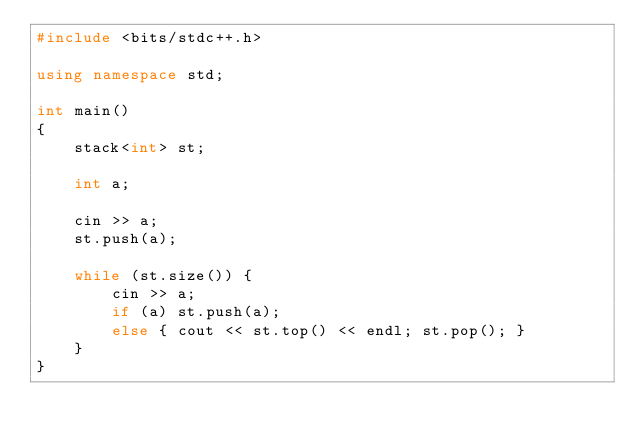<code> <loc_0><loc_0><loc_500><loc_500><_C++_>#include <bits/stdc++.h>

using namespace std;

int main()
{
    stack<int> st;

    int a;

    cin >> a;
    st.push(a);

    while (st.size()) {
        cin >> a;
        if (a) st.push(a);
        else { cout << st.top() << endl; st.pop(); }
    }
}</code> 